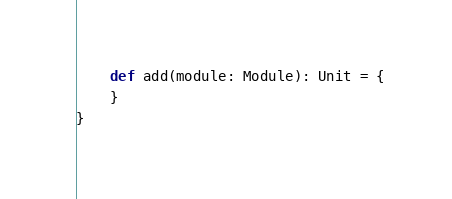Convert code to text. <code><loc_0><loc_0><loc_500><loc_500><_Scala_>    def add(module: Module): Unit = {
    }
}
</code> 